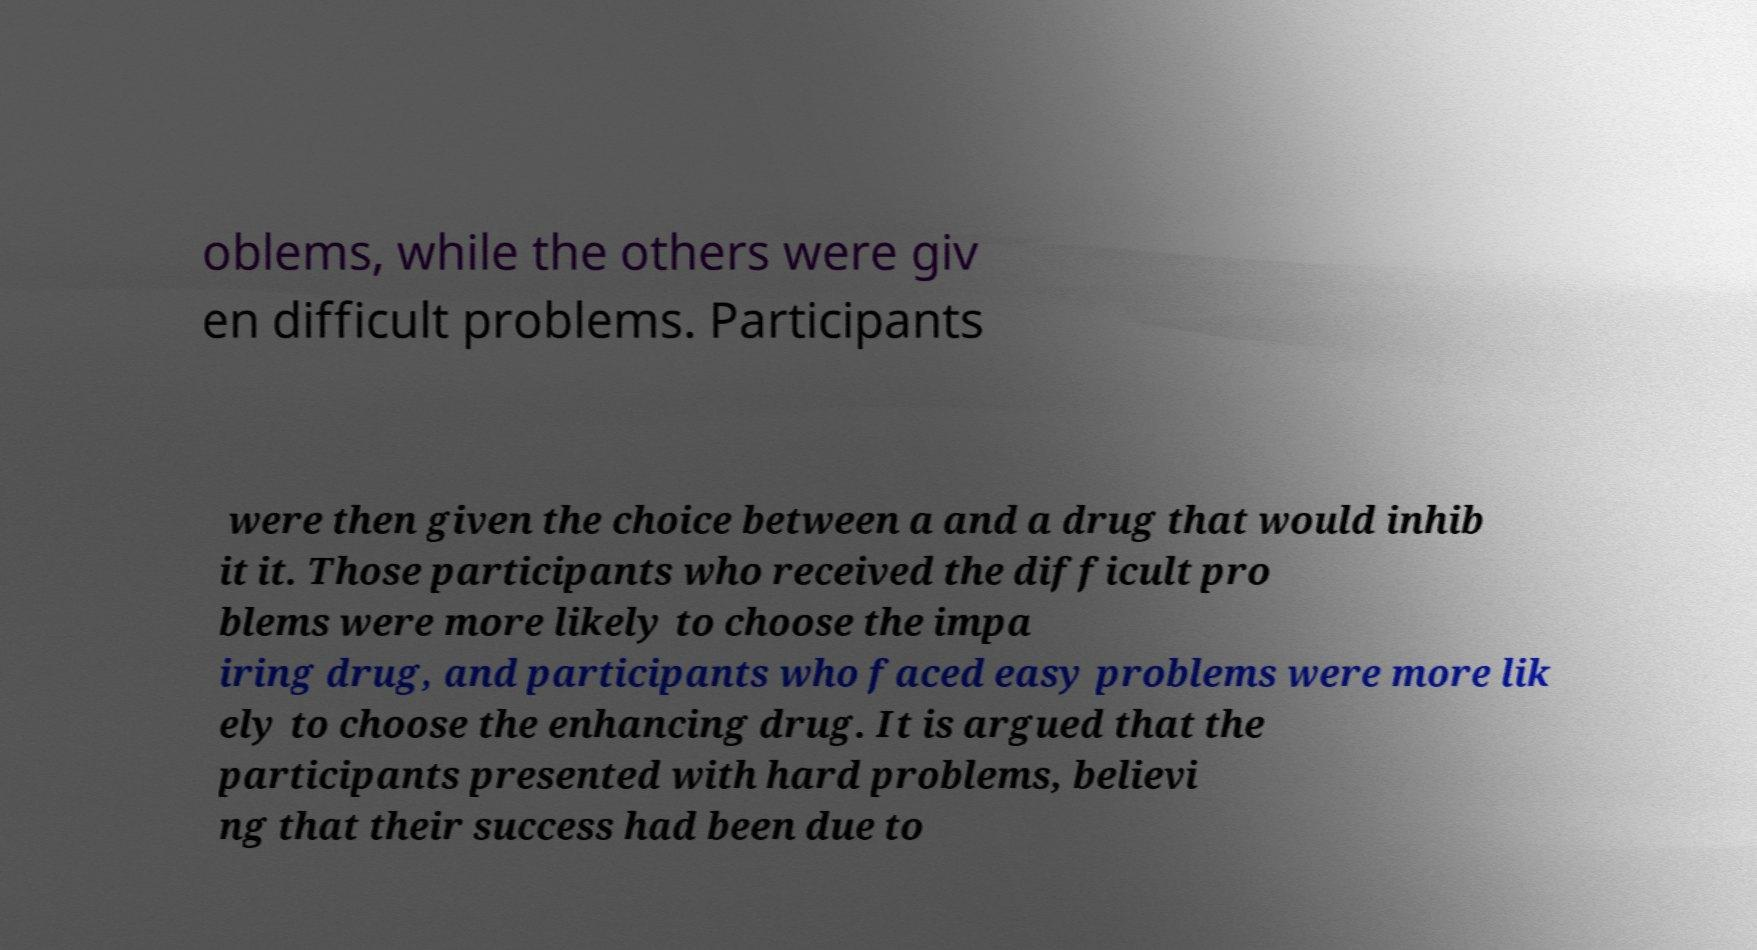Can you accurately transcribe the text from the provided image for me? oblems, while the others were giv en difficult problems. Participants were then given the choice between a and a drug that would inhib it it. Those participants who received the difficult pro blems were more likely to choose the impa iring drug, and participants who faced easy problems were more lik ely to choose the enhancing drug. It is argued that the participants presented with hard problems, believi ng that their success had been due to 